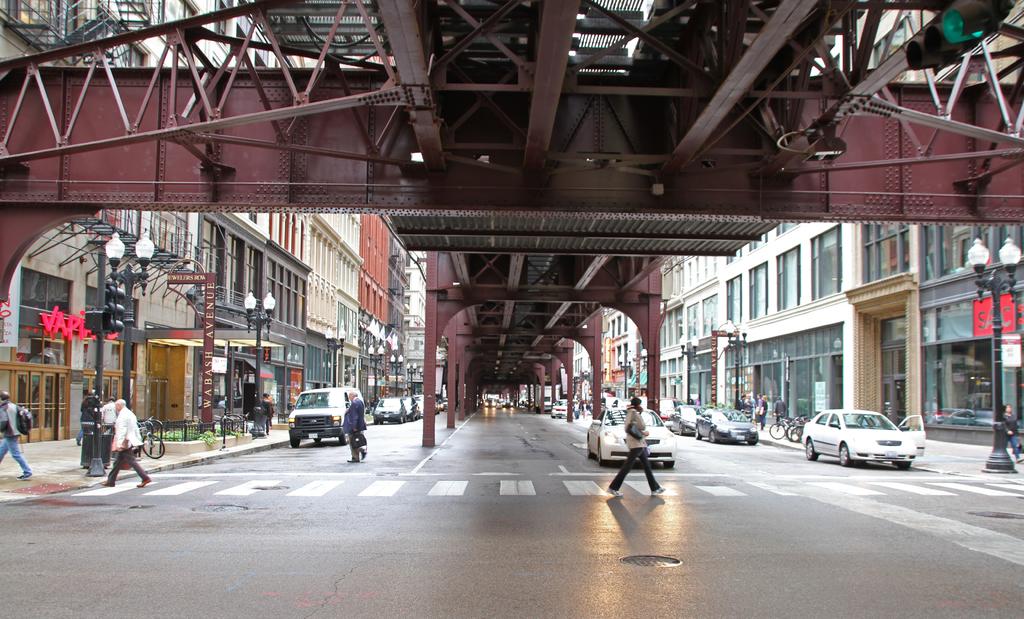What 3 large red letters are on the left?
Your answer should be compact. Vap. What are the letters in red located on the left?
Give a very brief answer. Vap. 